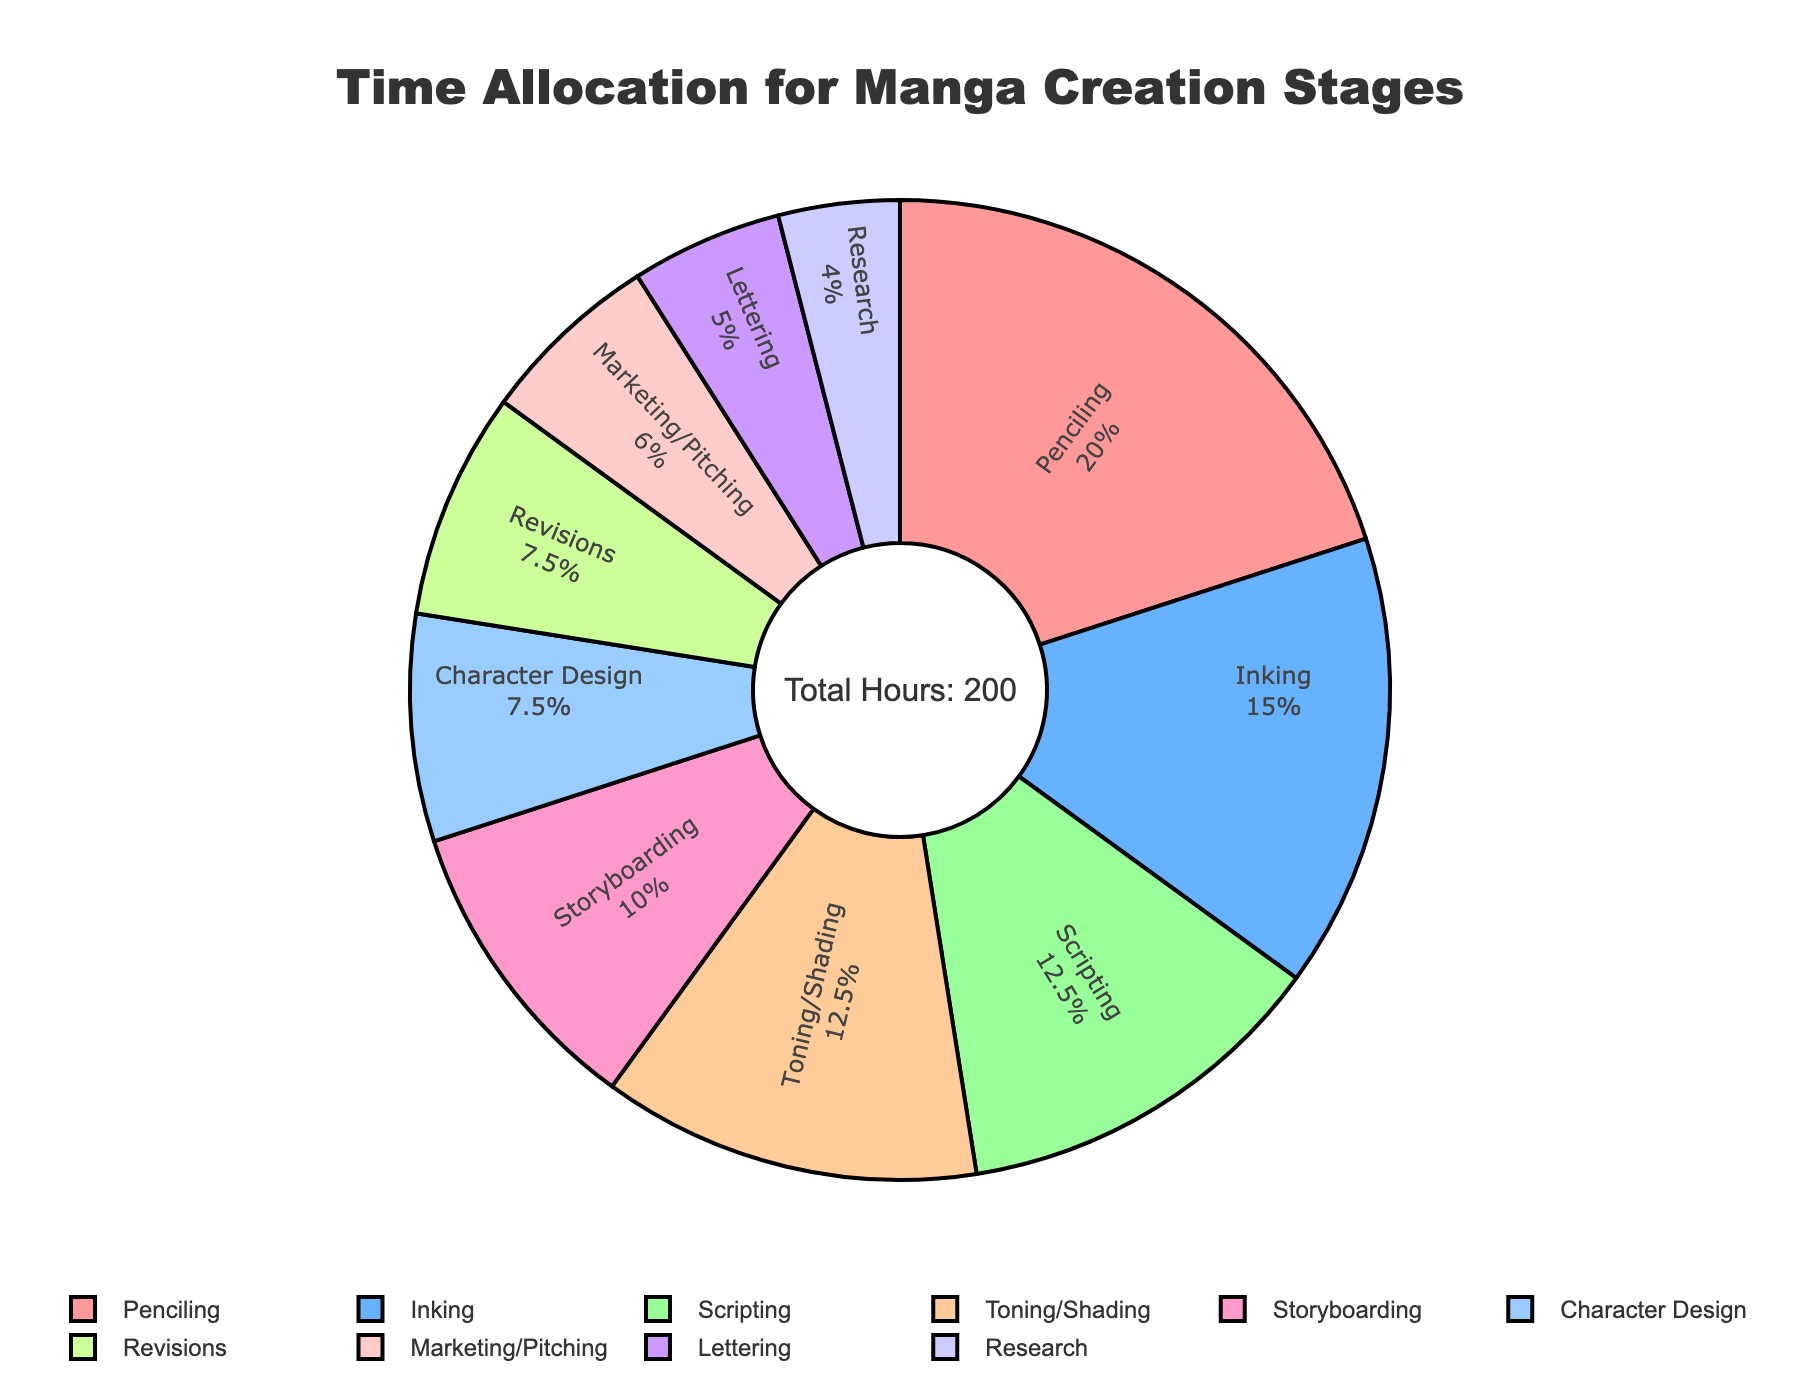Which stage takes the highest percentage of time? The largest segment in the pie chart, occupying the highest percentage, represents the stage that takes the most time. In this case, it's the "Penciling" stage.
Answer: Penciling Which two stages together take up the most significant portion of time? We need to find the combination of two largest sections. Here, "Penciling" and "Inking" are the two largest segments. Adding their hours, 40 + 30 = 70, accounts for the most significant portion.
Answer: Penciling and Inking What's the total percentage time spent on "Storyboarding" and "Character Design"? "Storyboarding" accounts for 20 hours and "Character Design" for 15. Adding them gives 20 + 15 = 35 hours. To find the percentage, (35 / 200) * 100 = 17.5%.
Answer: 17.5% Is the "Marketing/Pitching" stage longer than the "Lettering" stage? By comparing the segments labeled "Marketing/Pitching" and "Lettering" in the pie chart, "Marketing/Pitching" has 12 hours while "Lettering" has 10 hours. Since 12 is greater than 10, "Marketing/Pitching" is longer.
Answer: Yes Which stages have equal time allocations? By examining the segments and their labels, both "Character Design" and "Revisions" have 15 hours each. Similarly, "Scripting" and "Toning/Shading" both have 25 hours each.
Answer: Character Design & Revisions, Scripting & Toning/Shading What percentage of the total time is dedicated to "Research"? "Research" is allocated 8 hours. To find its percentage, (8 / 200) * 100 = 4%.
Answer: 4% How does the time spent on "Inking" compare to "Toning/Shading"? "Inking" occupies 30 hours, while "Toning/Shading" is 25 hours. Since 30 is greater than 25, more time is spent on "Inking."
Answer: More What fraction of the time is used for "Lettering" compared to the total time? "Lettering" has 10 hours, while the total time is 200. The fraction is 10/200, which simplifies to 1/20.
Answer: 1/20 